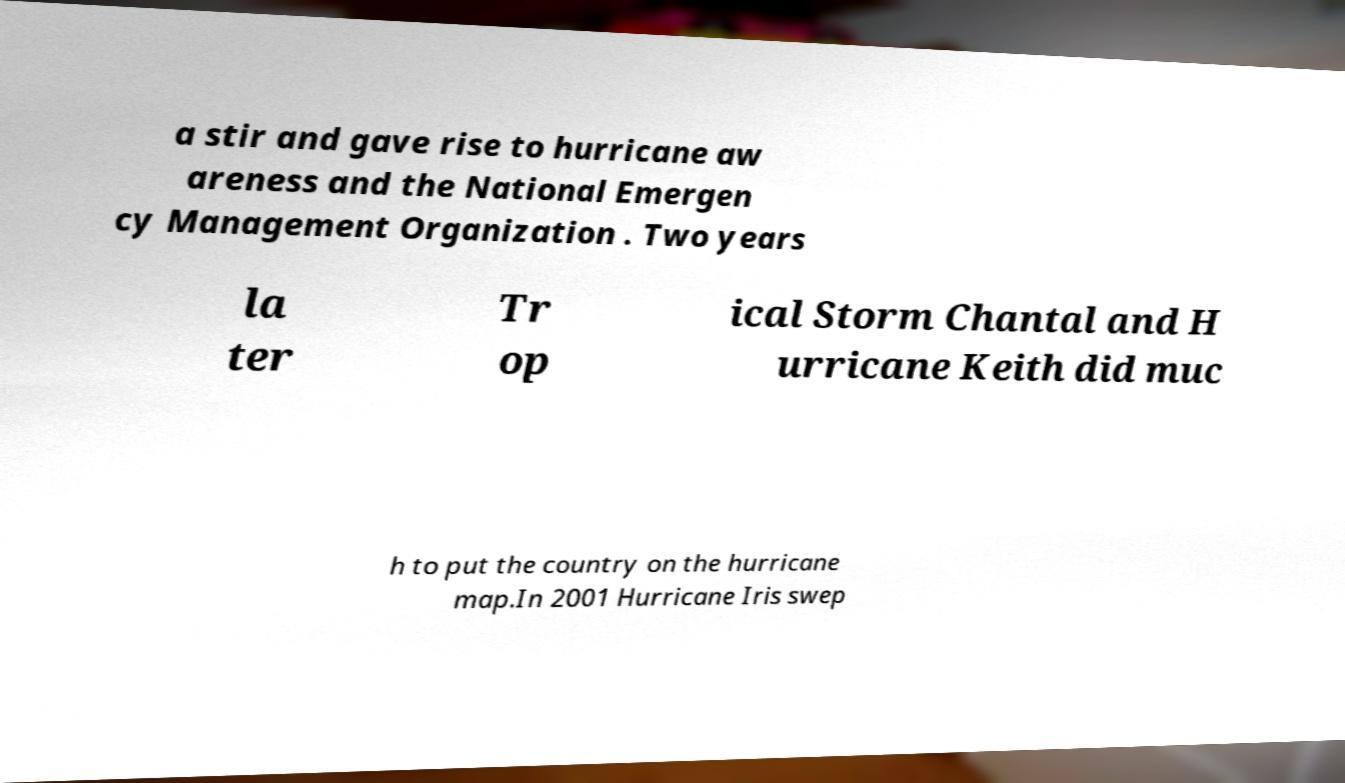Please read and relay the text visible in this image. What does it say? a stir and gave rise to hurricane aw areness and the National Emergen cy Management Organization . Two years la ter Tr op ical Storm Chantal and H urricane Keith did muc h to put the country on the hurricane map.In 2001 Hurricane Iris swep 